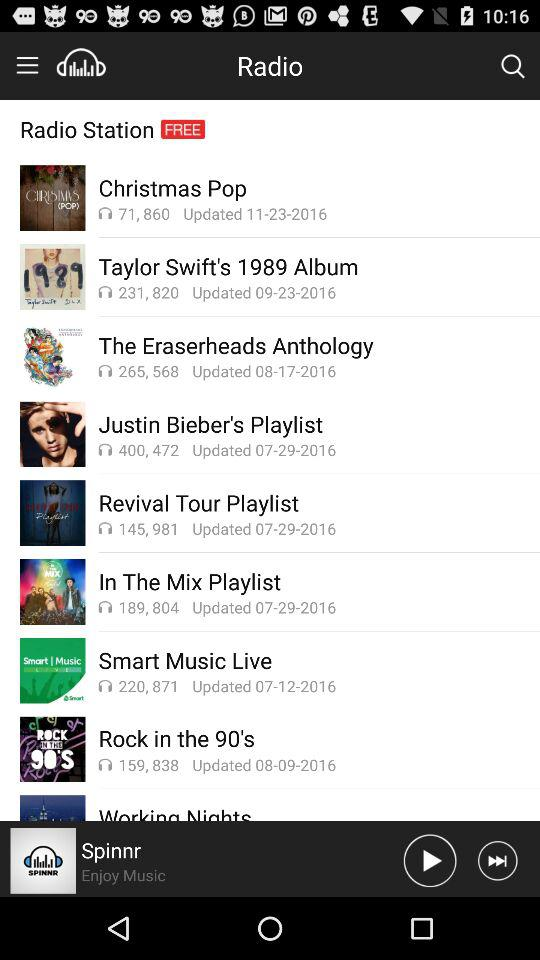When is Taylor Swift's 1989 album updated? Taylor Swift's 1989 album is updated on September 23, 2016. 